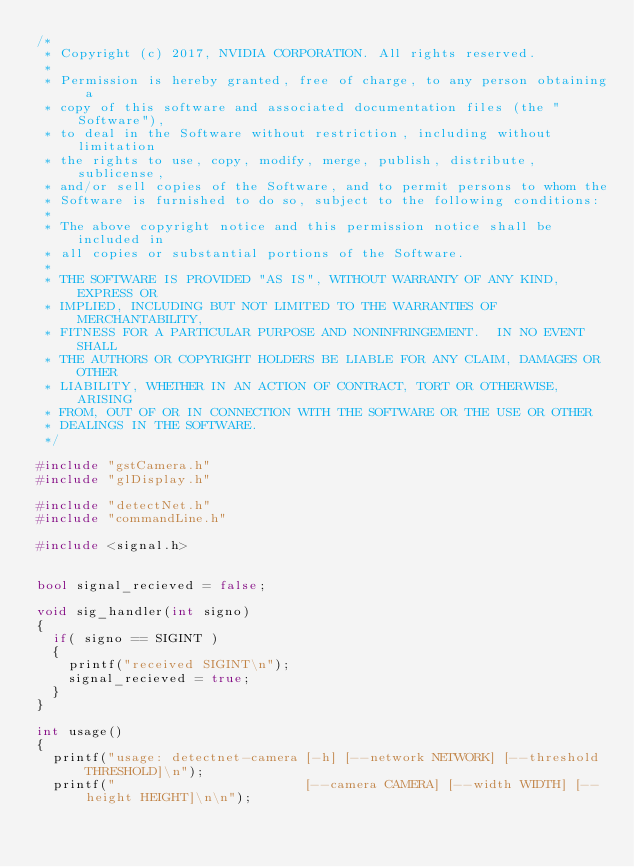Convert code to text. <code><loc_0><loc_0><loc_500><loc_500><_C++_>/*
 * Copyright (c) 2017, NVIDIA CORPORATION. All rights reserved.
 *
 * Permission is hereby granted, free of charge, to any person obtaining a
 * copy of this software and associated documentation files (the "Software"),
 * to deal in the Software without restriction, including without limitation
 * the rights to use, copy, modify, merge, publish, distribute, sublicense,
 * and/or sell copies of the Software, and to permit persons to whom the
 * Software is furnished to do so, subject to the following conditions:
 *
 * The above copyright notice and this permission notice shall be included in
 * all copies or substantial portions of the Software.
 *
 * THE SOFTWARE IS PROVIDED "AS IS", WITHOUT WARRANTY OF ANY KIND, EXPRESS OR
 * IMPLIED, INCLUDING BUT NOT LIMITED TO THE WARRANTIES OF MERCHANTABILITY,
 * FITNESS FOR A PARTICULAR PURPOSE AND NONINFRINGEMENT.  IN NO EVENT SHALL
 * THE AUTHORS OR COPYRIGHT HOLDERS BE LIABLE FOR ANY CLAIM, DAMAGES OR OTHER
 * LIABILITY, WHETHER IN AN ACTION OF CONTRACT, TORT OR OTHERWISE, ARISING
 * FROM, OUT OF OR IN CONNECTION WITH THE SOFTWARE OR THE USE OR OTHER
 * DEALINGS IN THE SOFTWARE.
 */

#include "gstCamera.h"
#include "glDisplay.h"

#include "detectNet.h"
#include "commandLine.h"

#include <signal.h>


bool signal_recieved = false;

void sig_handler(int signo)
{
	if( signo == SIGINT )
	{
		printf("received SIGINT\n");
		signal_recieved = true;
	}
}

int usage()
{
	printf("usage: detectnet-camera [-h] [--network NETWORK] [--threshold THRESHOLD]\n");
	printf("                        [--camera CAMERA] [--width WIDTH] [--height HEIGHT]\n\n");</code> 